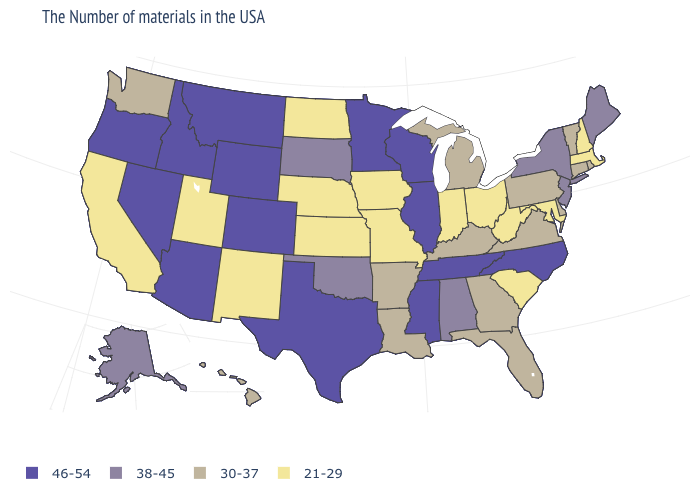What is the lowest value in the Northeast?
Answer briefly. 21-29. What is the value of Colorado?
Concise answer only. 46-54. Name the states that have a value in the range 21-29?
Short answer required. Massachusetts, New Hampshire, Maryland, South Carolina, West Virginia, Ohio, Indiana, Missouri, Iowa, Kansas, Nebraska, North Dakota, New Mexico, Utah, California. What is the value of Virginia?
Give a very brief answer. 30-37. Which states hav the highest value in the MidWest?
Quick response, please. Wisconsin, Illinois, Minnesota. Does Michigan have the lowest value in the MidWest?
Be succinct. No. Name the states that have a value in the range 30-37?
Keep it brief. Rhode Island, Vermont, Connecticut, Delaware, Pennsylvania, Virginia, Florida, Georgia, Michigan, Kentucky, Louisiana, Arkansas, Washington, Hawaii. What is the highest value in the West ?
Short answer required. 46-54. What is the value of Ohio?
Keep it brief. 21-29. What is the value of Minnesota?
Concise answer only. 46-54. What is the highest value in the South ?
Be succinct. 46-54. What is the value of Arizona?
Quick response, please. 46-54. Among the states that border Delaware , which have the highest value?
Give a very brief answer. New Jersey. Among the states that border Tennessee , does Georgia have the highest value?
Write a very short answer. No. Among the states that border Arkansas , which have the lowest value?
Concise answer only. Missouri. 